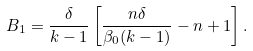Convert formula to latex. <formula><loc_0><loc_0><loc_500><loc_500>B _ { 1 } = \frac { \delta } { k - 1 } \left [ \frac { n \delta } { \beta _ { 0 } ( k - 1 ) } - n + 1 \right ] .</formula> 